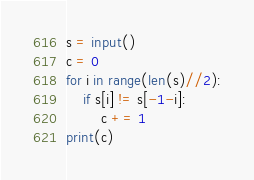Convert code to text. <code><loc_0><loc_0><loc_500><loc_500><_Python_>s = input()
c = 0
for i in range(len(s)//2):
    if s[i] != s[-1-i]:
        c += 1
print(c)</code> 